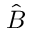<formula> <loc_0><loc_0><loc_500><loc_500>\hat { B }</formula> 